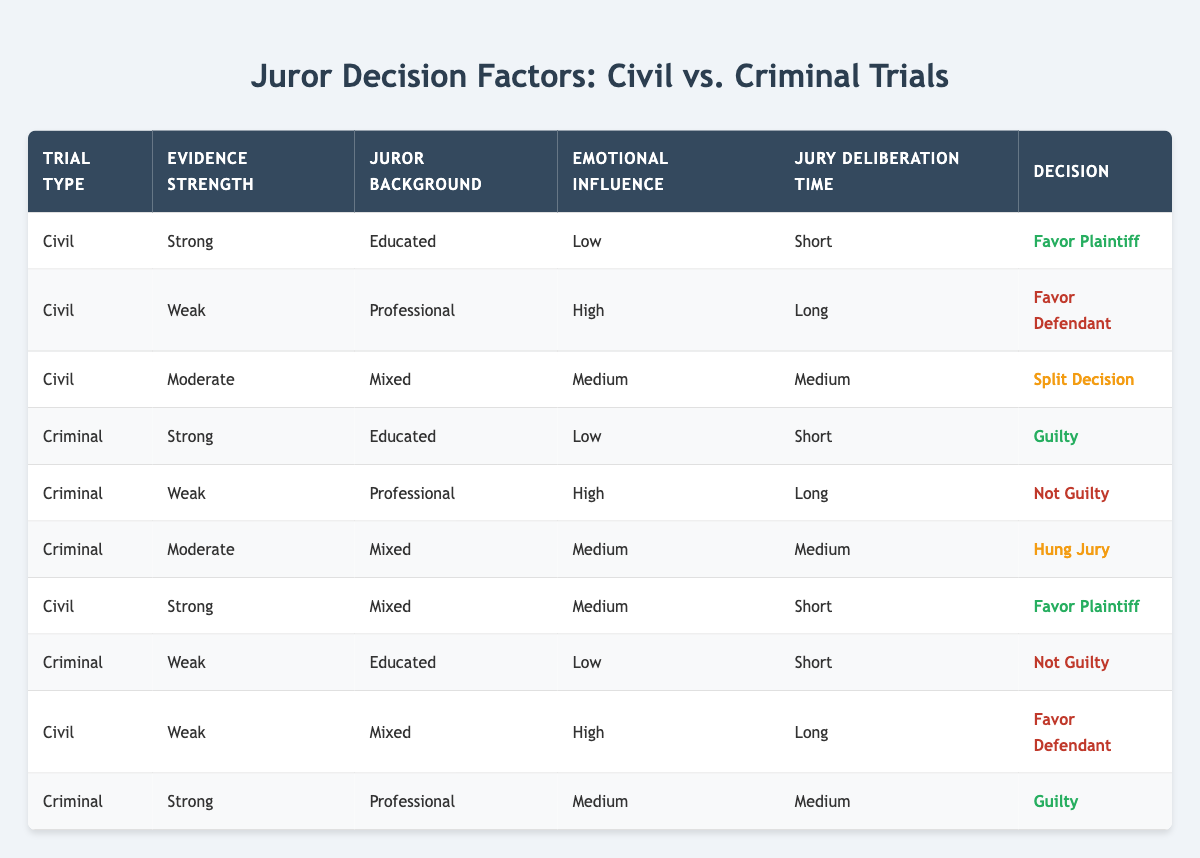What is the decision in cases where the evidence strength is strong in civil trials? There are two cases in civil trials with strong evidence strength. Both cases favor the plaintiff.
Answer: Favor Plaintiff How many juror decisions are influenced by high emotional influence in civil trials? There are two civil trial cases where emotional influence is high (one with weak evidence and another with weak evidence and a mixed background).
Answer: 2 Is it true that educated jurors favor the defendant in any trial? In the table, no cases show educated jurors favoring the defendant; they made decisions in favor of the plaintiff in civil trials and guilty in criminal trials.
Answer: No What is the average jury deliberation time for decisions favoring the plaintiff? Decisions favoring the plaintiff have deliberation times of short (2 cases), medium (1 case), and long, which results in an average of (short + medium + long) = (1 + 2 + 3 = 6) and divided by 4 = 1.5 rounded gives 2. Average deliberation time rounded is medium.
Answer: Medium Which trial type has a decision of "Hung Jury"? The table indicates that the decision of "Hung Jury" only appears in a criminal trial under moderate evidence strength with a mixed background.
Answer: Criminal How many rows depict a decision of "Not Guilty"? There are two cases where the decision is "Not Guilty," one for weak evidence with an educated background and another with weak evidence and a professional jury.
Answer: 2 What is the decision for the trial with mixed juror backgrounds and medium emotional influence? In the table, there are two such cases in civil and criminal trials; the civil trial results in "Split Decision," and the criminal trial results in "Hung Jury."
Answer: Split Decision and Hung Jury In which trial type do jurors predominantly prefer the plaintiff? Jurors prefer the plaintiff in civil trials, as evidenced by the two cases favoring the plaintiff.
Answer: Civil Trials 